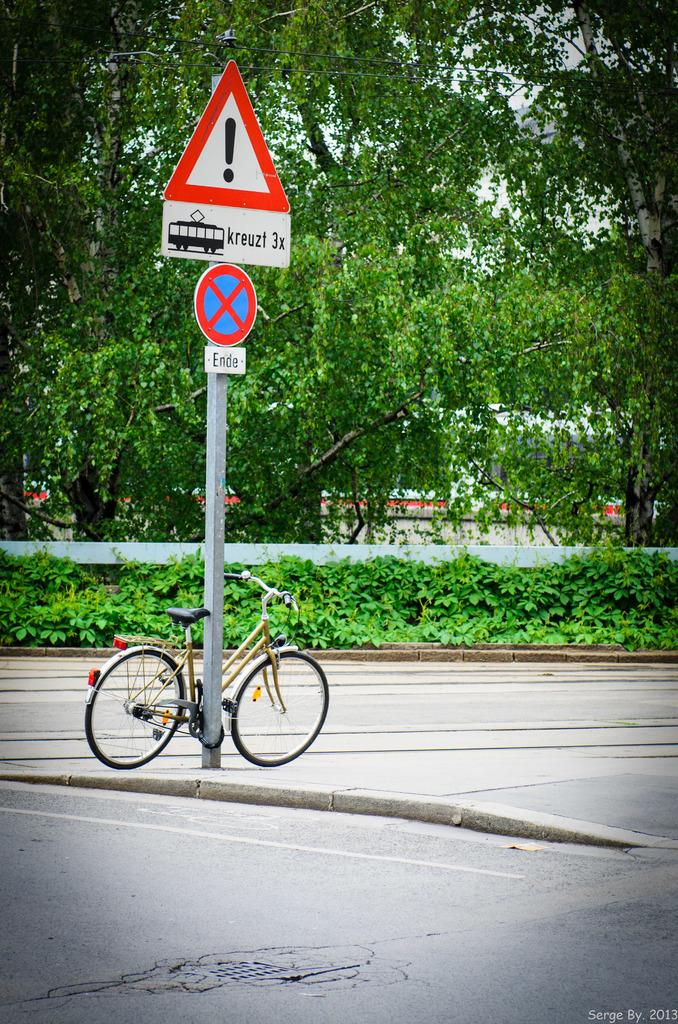<image>
Share a concise interpretation of the image provided. A no enter sign (ende) n a sign to let the drivers know that there is a rail line here 